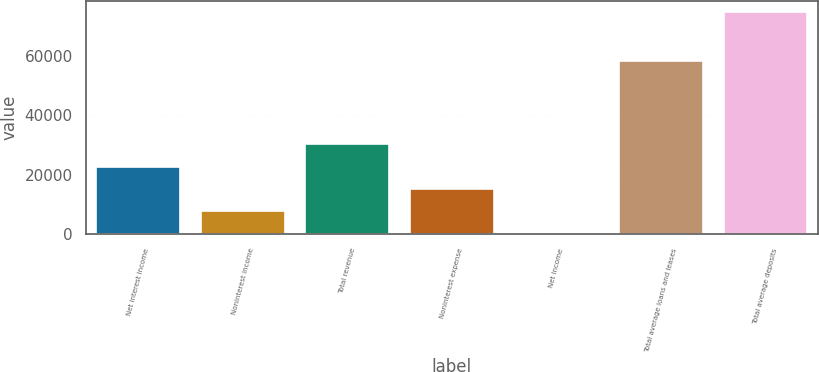Convert chart to OTSL. <chart><loc_0><loc_0><loc_500><loc_500><bar_chart><fcel>Net interest income<fcel>Noninterest income<fcel>Total revenue<fcel>Noninterest expense<fcel>Net income<fcel>Total average loans and leases<fcel>Total average deposits<nl><fcel>22778.3<fcel>7894.1<fcel>30220.4<fcel>15336.2<fcel>452<fcel>58371<fcel>74873<nl></chart> 